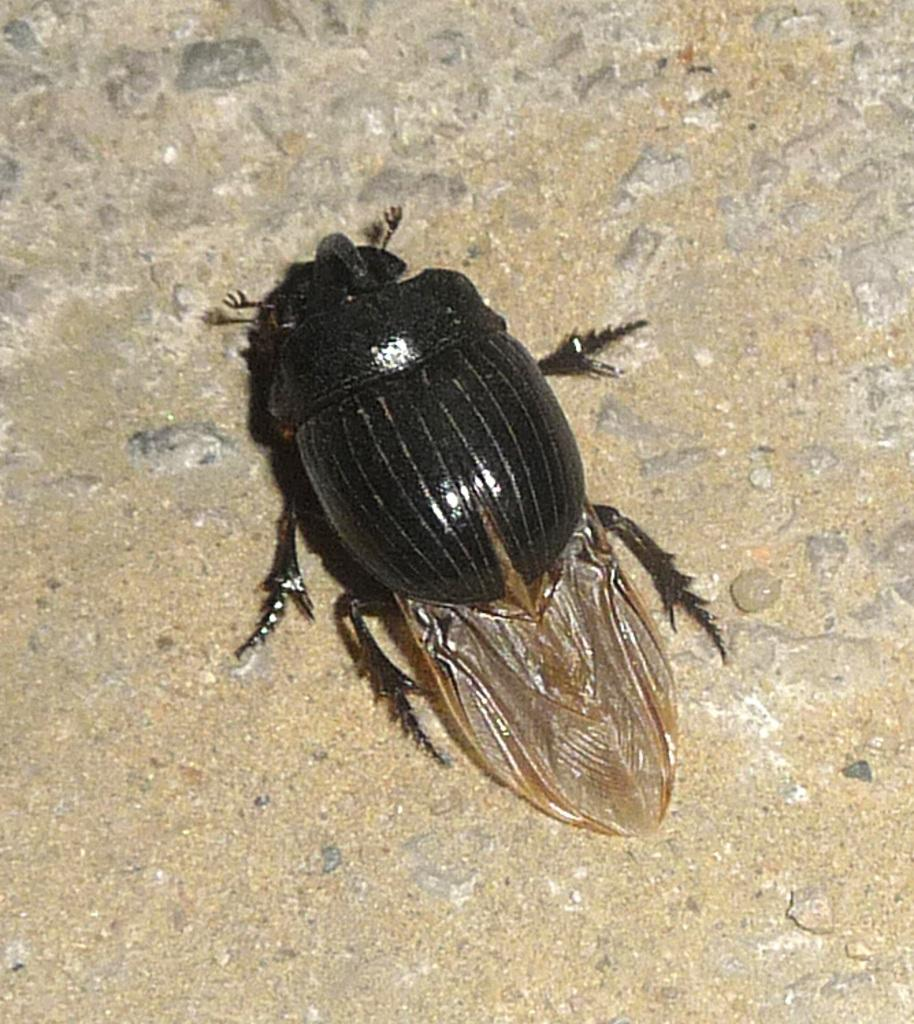What type of creature is present in the image? There is an insect in the image. Where is the insect located in the image? The insect is on the floor. What type of music is the insect playing on the guitar in the image? There is no guitar present in the image, and the insect is not playing any music. 